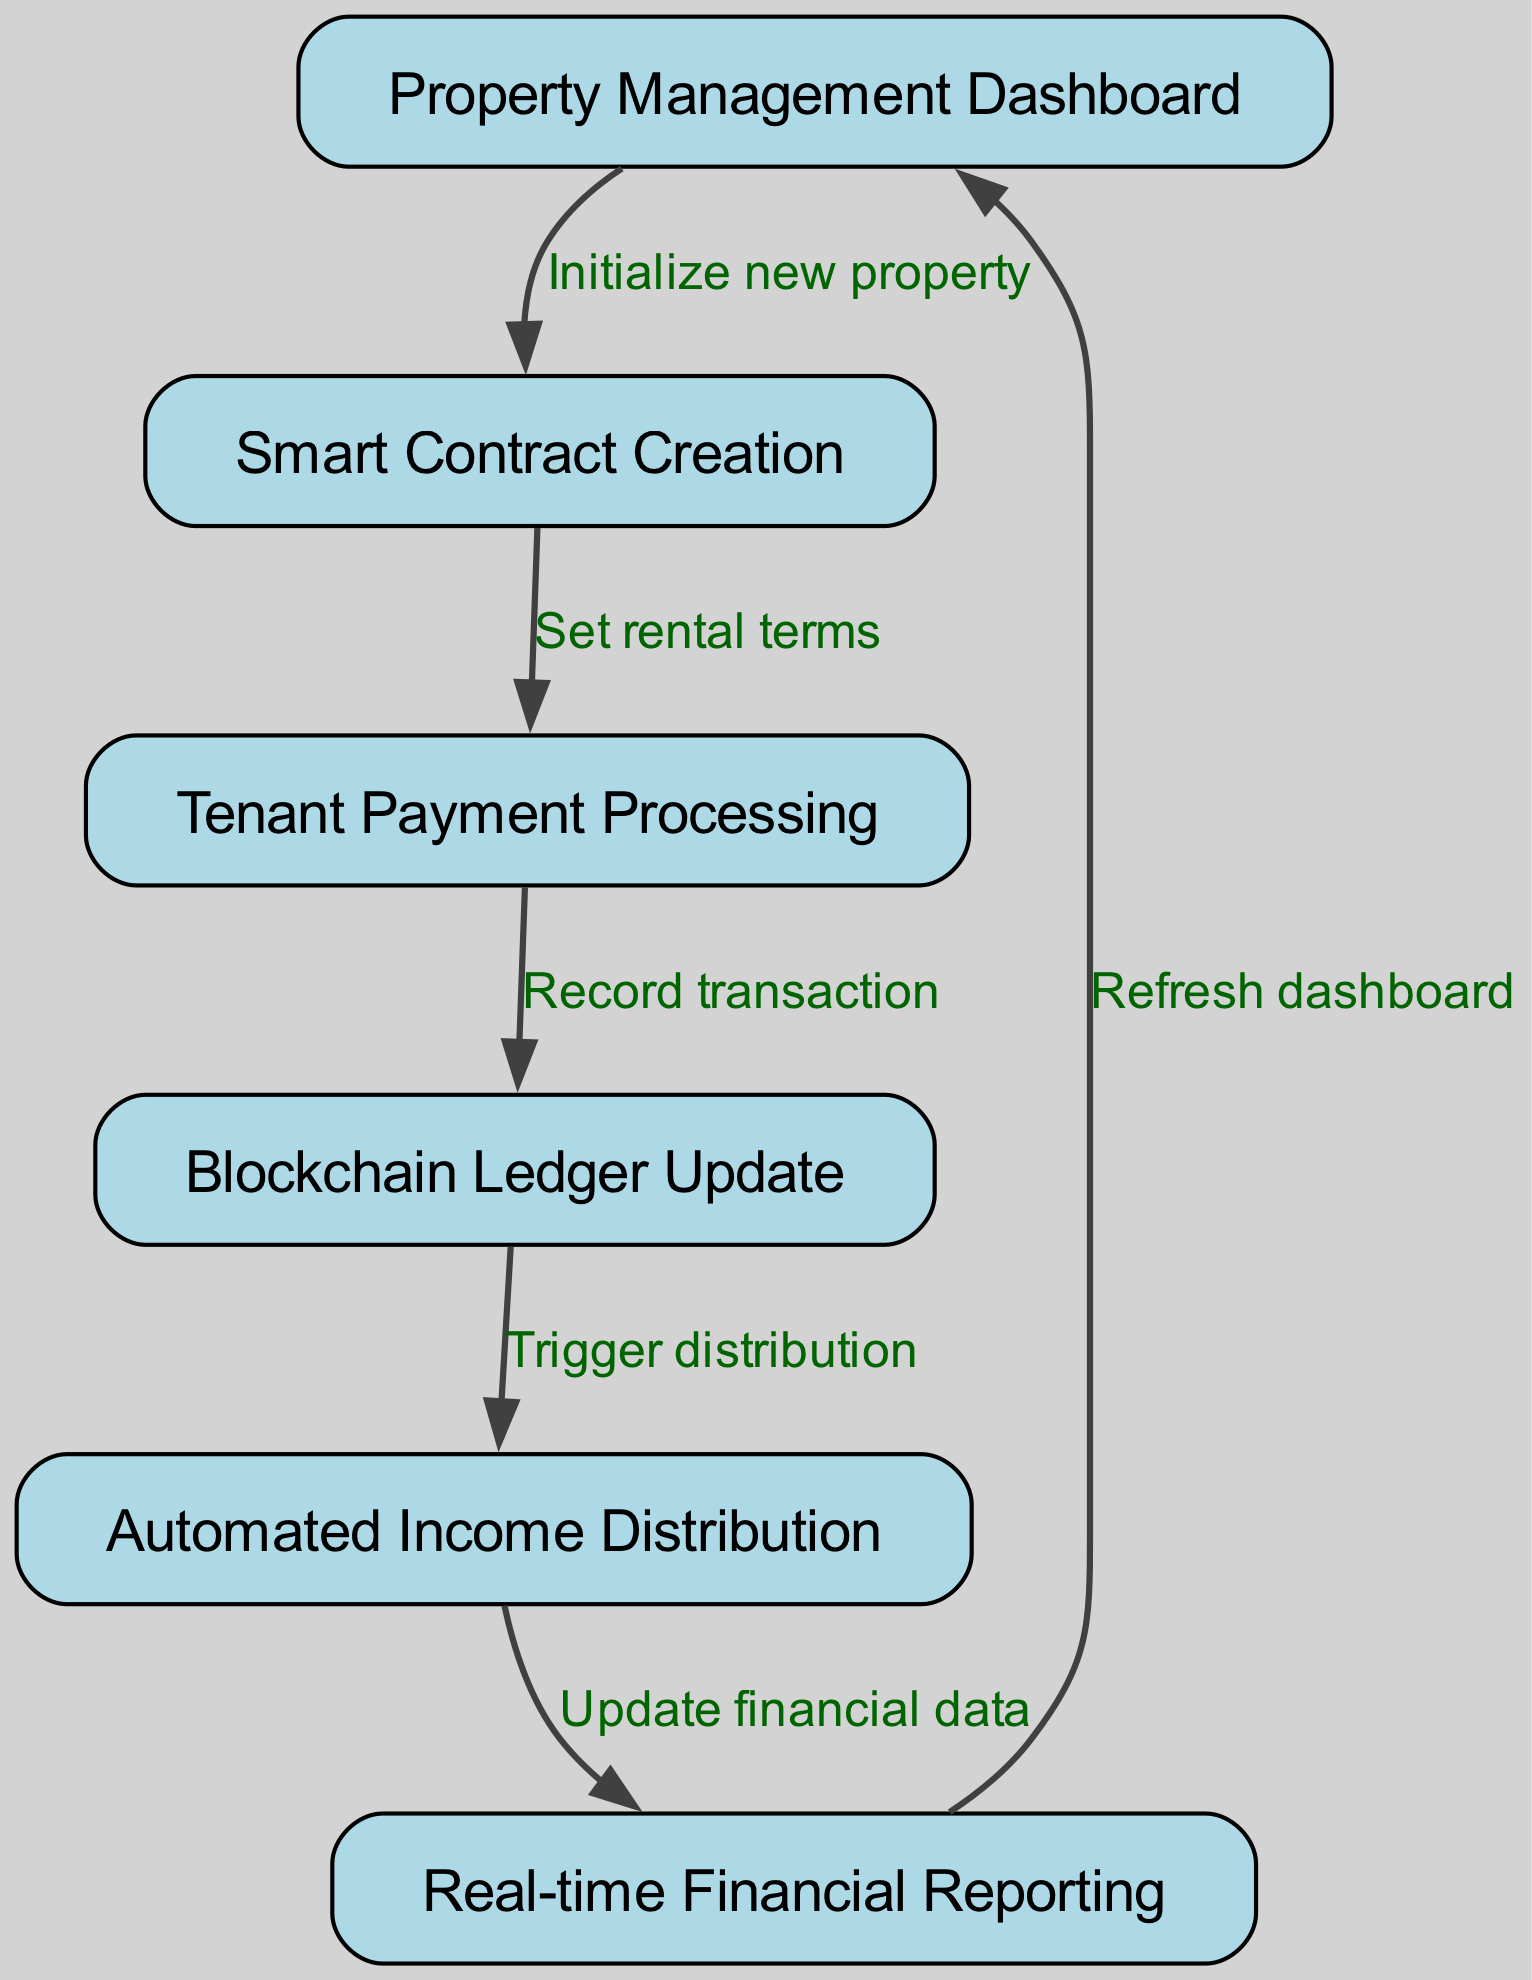What is the first step in the flowchart? The flowchart begins with the "Property Management Dashboard," which is the starting point for initializing a new property.
Answer: Property Management Dashboard How many nodes are present in the diagram? By counting the nodes listed, there are a total of six distinct nodes in the diagram that contribute to the rental income tracking and distribution process.
Answer: 6 What action follows "Smart Contract Creation"? The next action in the flowchart after "Smart Contract Creation" is "Tenant Payment Processing," as indicated by the directed edge connecting these two nodes.
Answer: Tenant Payment Processing What is the final node in the flowchart? The last node in the flowchart is "Real-time Financial Reporting," which serves to refresh the data on the dashboard following automated income distribution.
Answer: Real-time Financial Reporting Which node is connected to "Automated Income Distribution"? "Automated Income Distribution" is directly connected to "Real-time Financial Reporting," which follows as the process updates the financial data post-distribution.
Answer: Real-time Financial Reporting What triggers the income distribution process? The income distribution process is triggered by the "Blockchain Ledger Update" which indicates that the rental transactions have been recorded on the blockchain.
Answer: Blockchain Ledger Update Which node has the most incoming edges? The "Real-time Financial Reporting" node has the most incoming edges as it is the endpoint for the previous two processes: "Automated Income Distribution" and "Refresh dashboard."
Answer: Real-time Financial Reporting What is the relationship between "Tenant Payment Processing" and "Blockchain Ledger Update"? "Tenant Payment Processing" leads to "Blockchain Ledger Update" because it signifies that a transaction has occurred and needs to be recorded on the ledger.
Answer: Record transaction What updates the financial data in the system? The node "Automated Income Distribution," which follows the blockchain ledger update, is responsible for updating the financial data in the system.
Answer: Update financial data 